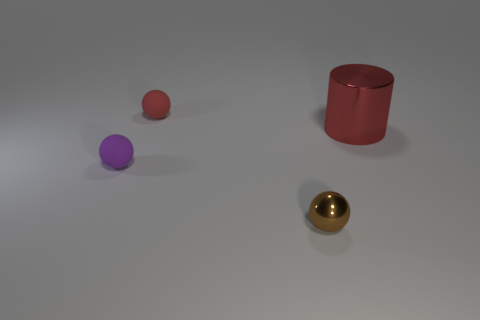Subtract all tiny matte balls. How many balls are left? 1 Subtract 1 cylinders. How many cylinders are left? 0 Add 4 small gray metal cylinders. How many objects exist? 8 Subtract all red spheres. How many spheres are left? 2 Subtract all cylinders. How many objects are left? 3 Subtract all red matte spheres. Subtract all brown metallic objects. How many objects are left? 2 Add 4 purple matte objects. How many purple matte objects are left? 5 Add 1 large brown shiny cubes. How many large brown shiny cubes exist? 1 Subtract 0 yellow balls. How many objects are left? 4 Subtract all green balls. Subtract all blue cylinders. How many balls are left? 3 